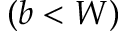Convert formula to latex. <formula><loc_0><loc_0><loc_500><loc_500>( b < W )</formula> 